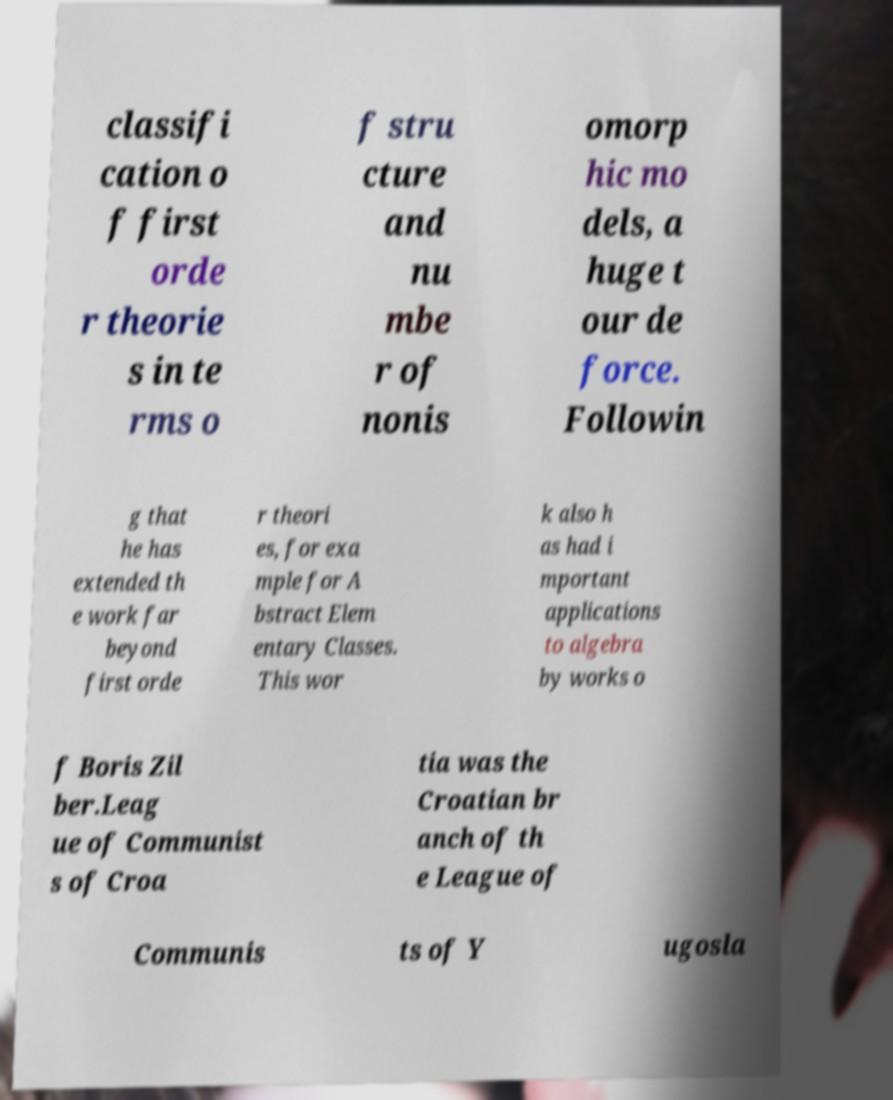For documentation purposes, I need the text within this image transcribed. Could you provide that? classifi cation o f first orde r theorie s in te rms o f stru cture and nu mbe r of nonis omorp hic mo dels, a huge t our de force. Followin g that he has extended th e work far beyond first orde r theori es, for exa mple for A bstract Elem entary Classes. This wor k also h as had i mportant applications to algebra by works o f Boris Zil ber.Leag ue of Communist s of Croa tia was the Croatian br anch of th e League of Communis ts of Y ugosla 